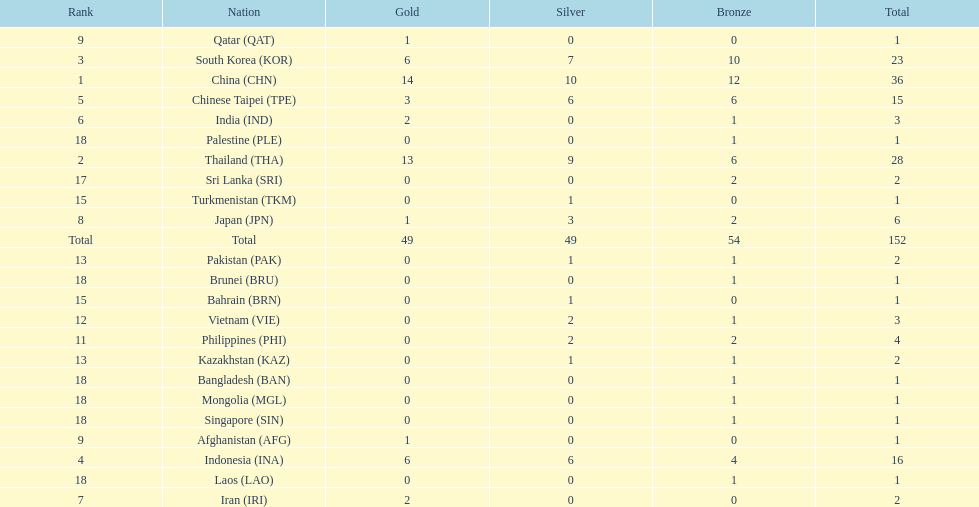How many nations received a medal in each gold, silver, and bronze? 6. 